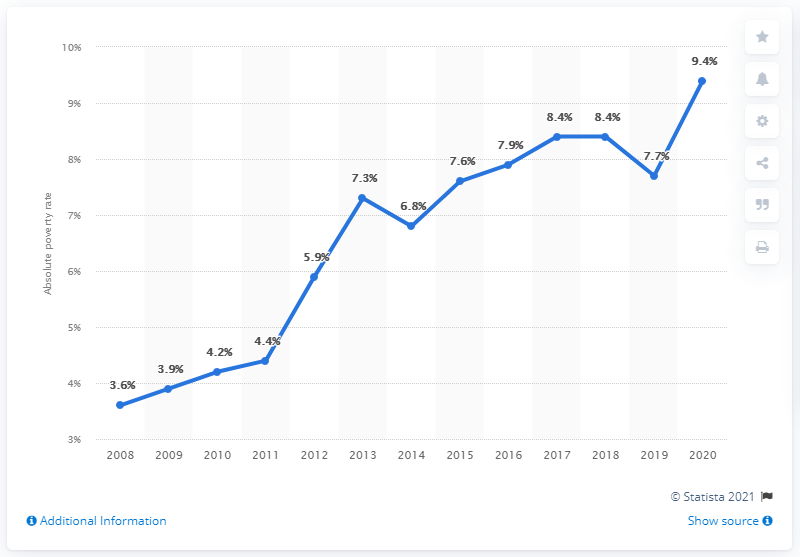Specify some key components in this picture. The year with the least absolute poverty rate in India was 2008. In 2019, the poverty rate experienced the most significant decline among all years, thereby indicating a positive trend. 